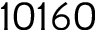<formula> <loc_0><loc_0><loc_500><loc_500>1 0 1 6 0</formula> 